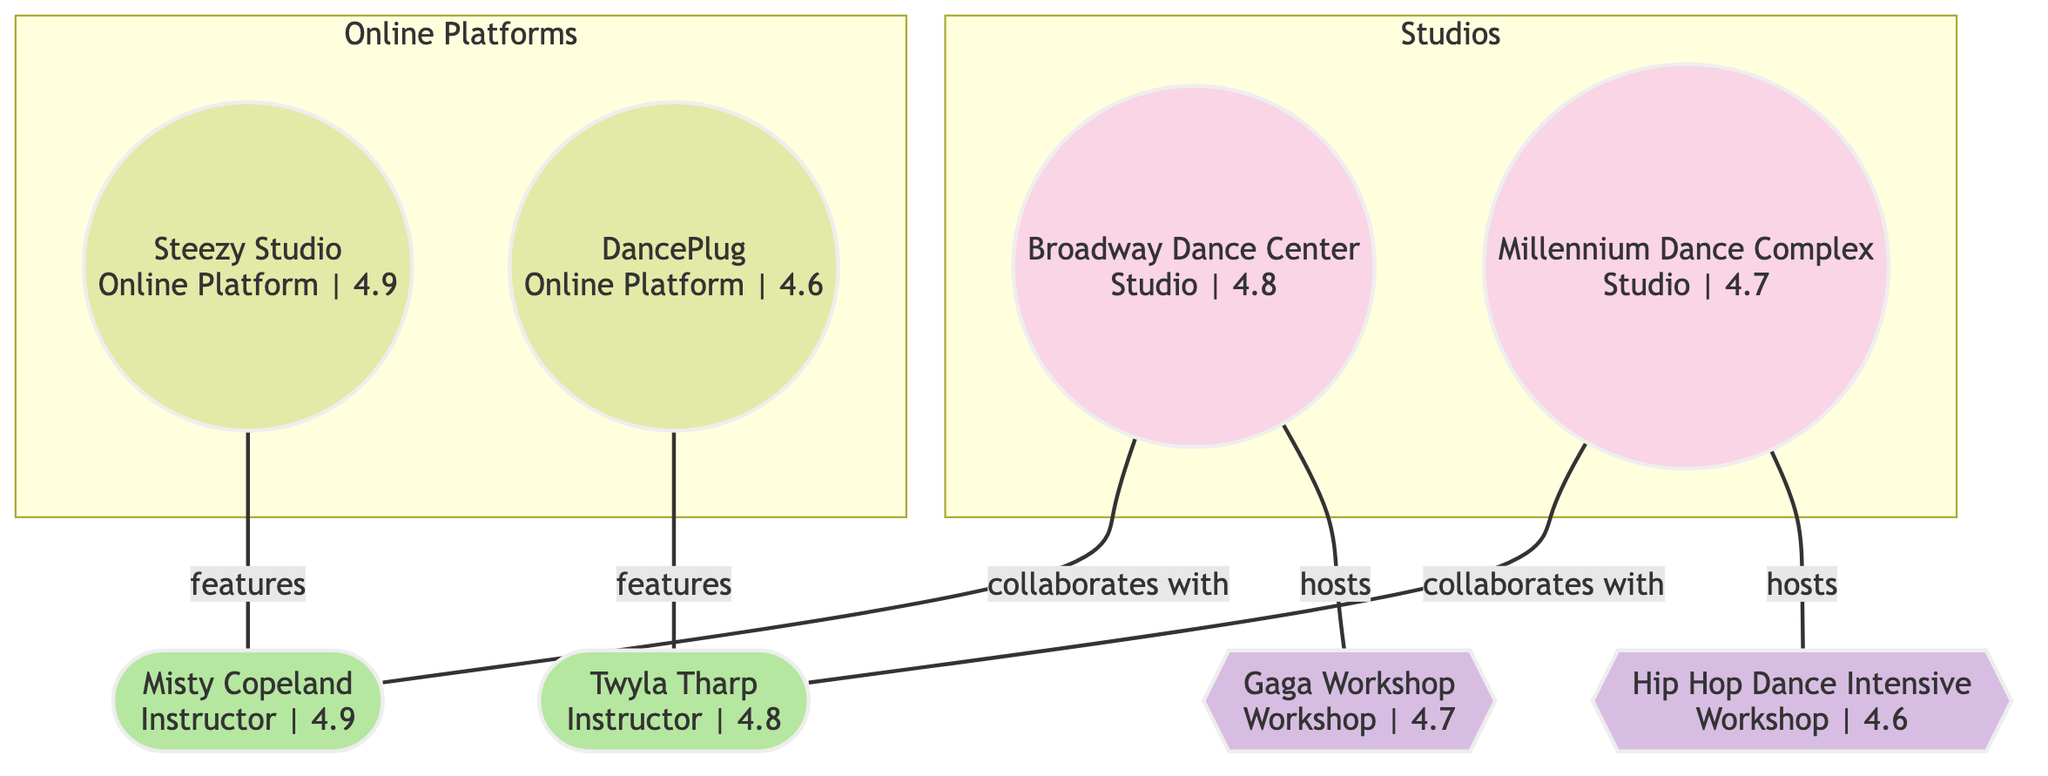What's the highest-rated online platform? By looking at the nodes, I can see "Steezy Studio" with a rating of 4.9 is listed among the online platforms. Therefore, it has the highest rating compared to "DancePlug," which has a rating of 4.6.
Answer: Steezy Studio Which studio hosts the "Gaga Workshop"? The diagram shows an edge labeled "hosts" connecting "Broadway Dance Center" to "Gaga Workshop." This indicates that "Broadway Dance Center" is the studio hosting this specific workshop.
Answer: Broadway Dance Center How many instructors are featured by online platforms? By examining the links, I count two "features" relationships; one with "Misty Copeland" and another with "Twyla Tharp." This indicates that both instructors are featured by the online platforms shown.
Answer: 2 What is the relationship between "Millennium Dance Complex" and "Twyla Tharp"? In the links section, there is a direct "collaborates_with" connection from "Millennium Dance Complex" to "Twyla Tharp," which shows their working relationship.
Answer: collaborates_with Which workshop is hosted by "Millennium Dance Complex"? In the links, there's a connection showing that "Millennium Dance Complex" hosts "Hip Hop Dance Intensive," which identifies the specific workshop associated with that studio.
Answer: Hip Hop Dance Intensive 